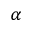Convert formula to latex. <formula><loc_0><loc_0><loc_500><loc_500>_ { \alpha }</formula> 